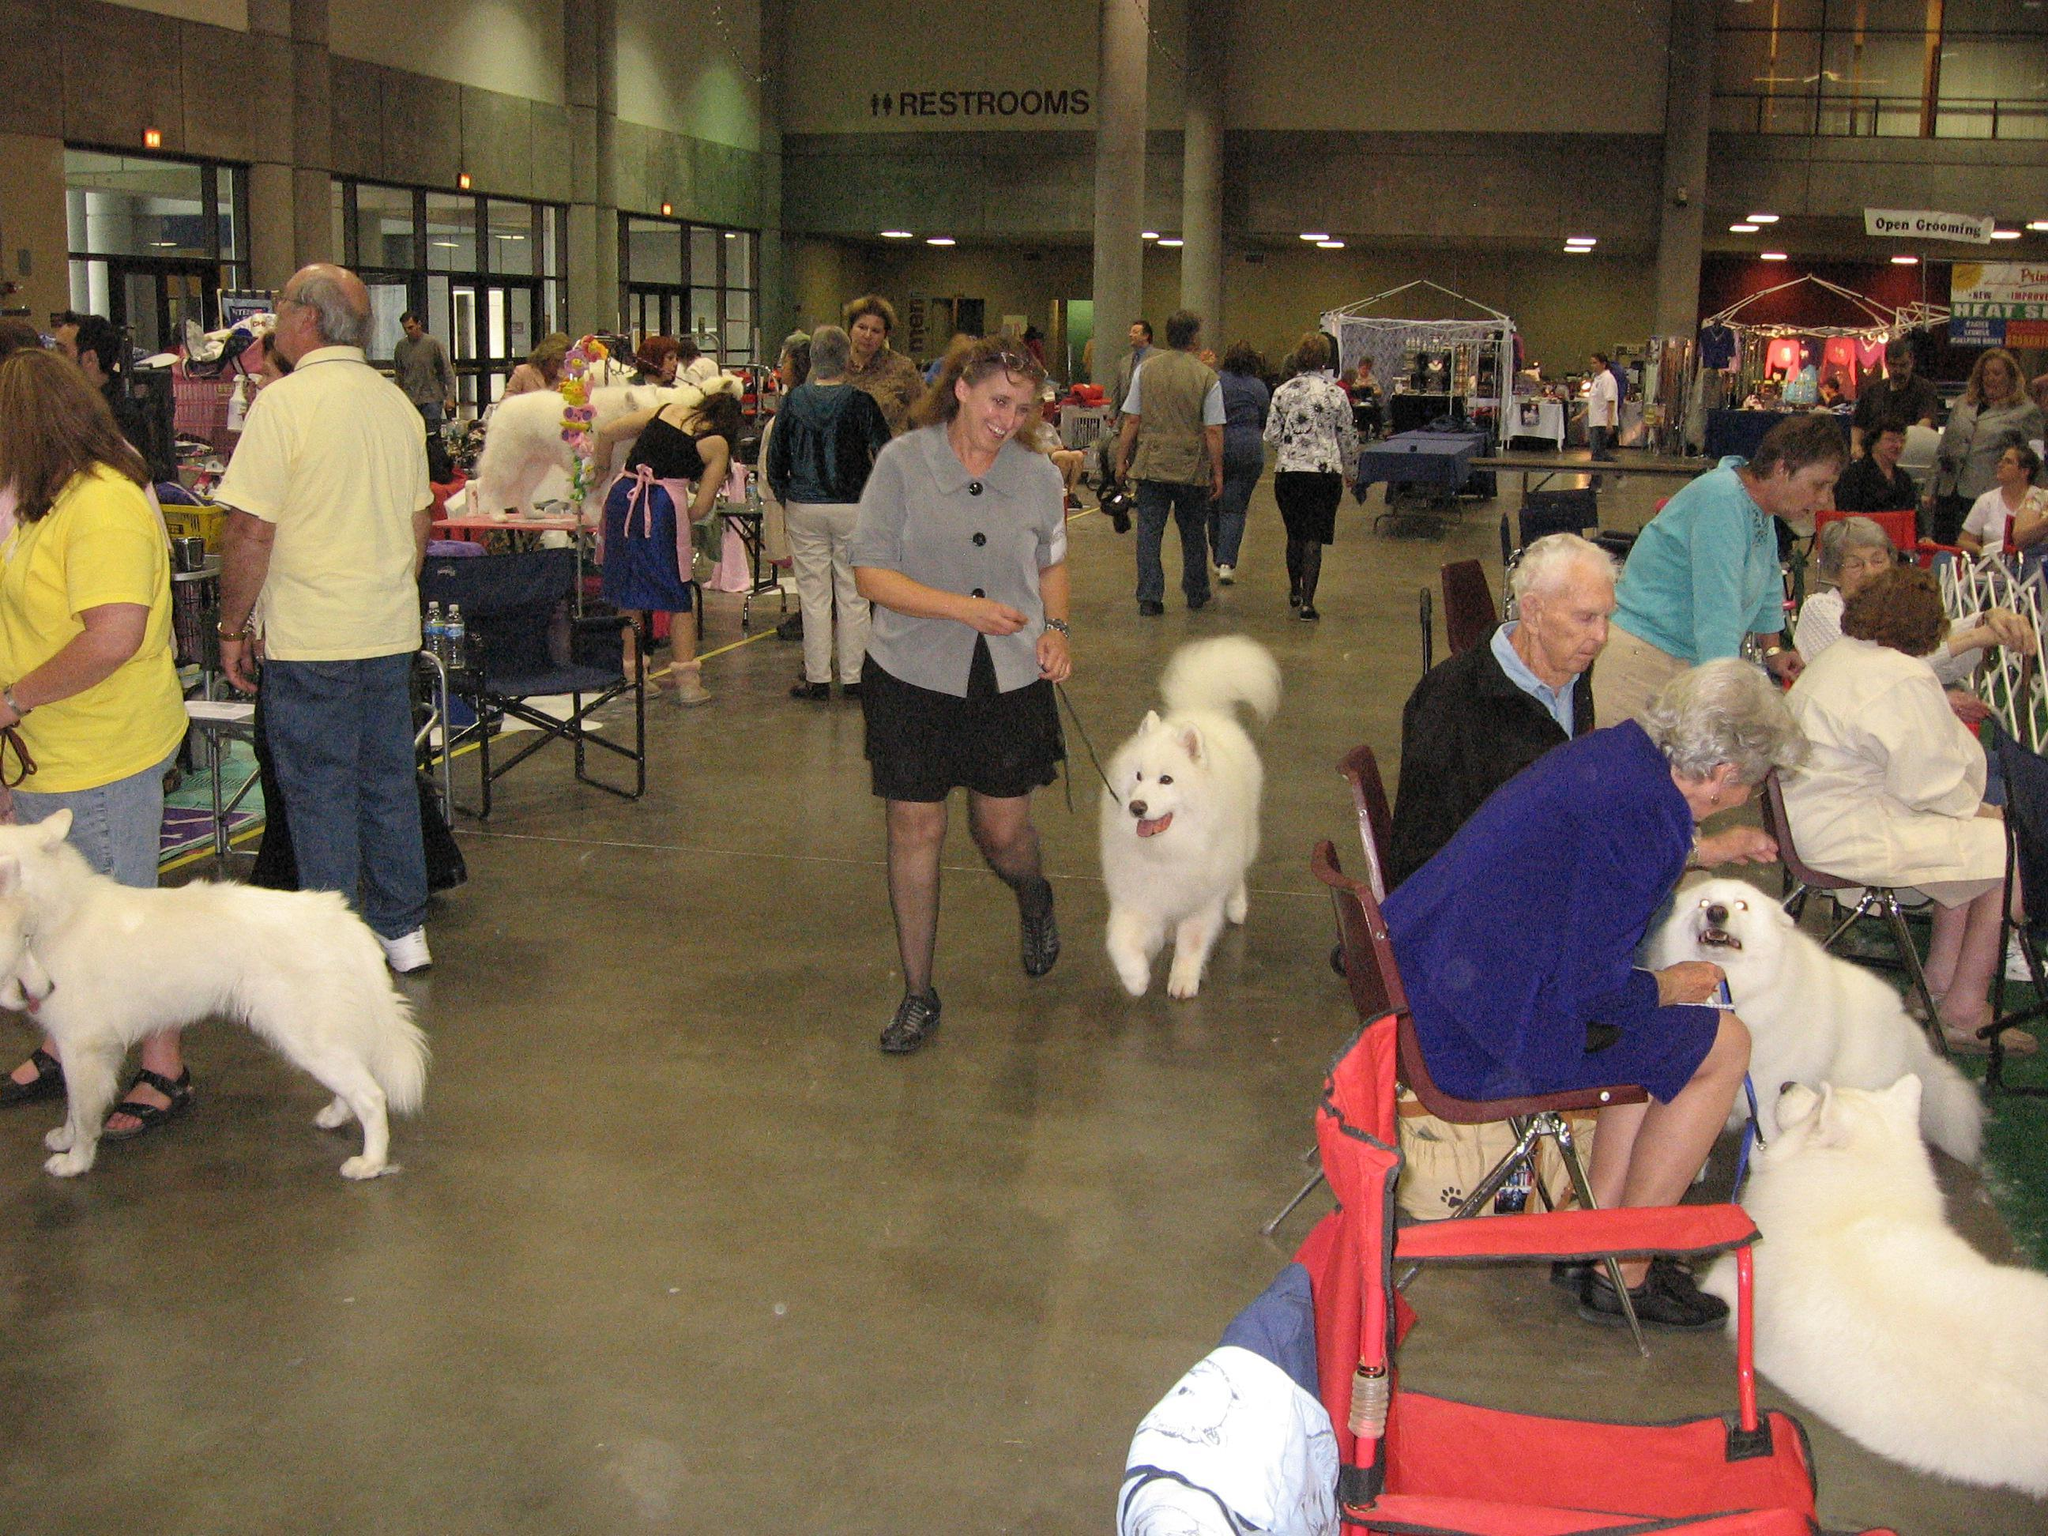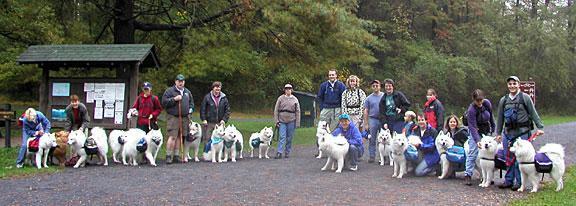The first image is the image on the left, the second image is the image on the right. Assess this claim about the two images: "One of the white dogs is lying on the green grass.". Correct or not? Answer yes or no. No. The first image is the image on the left, the second image is the image on the right. Given the left and right images, does the statement "An image with one dog shows a person standing outdoors next to the dog on a leash." hold true? Answer yes or no. No. 